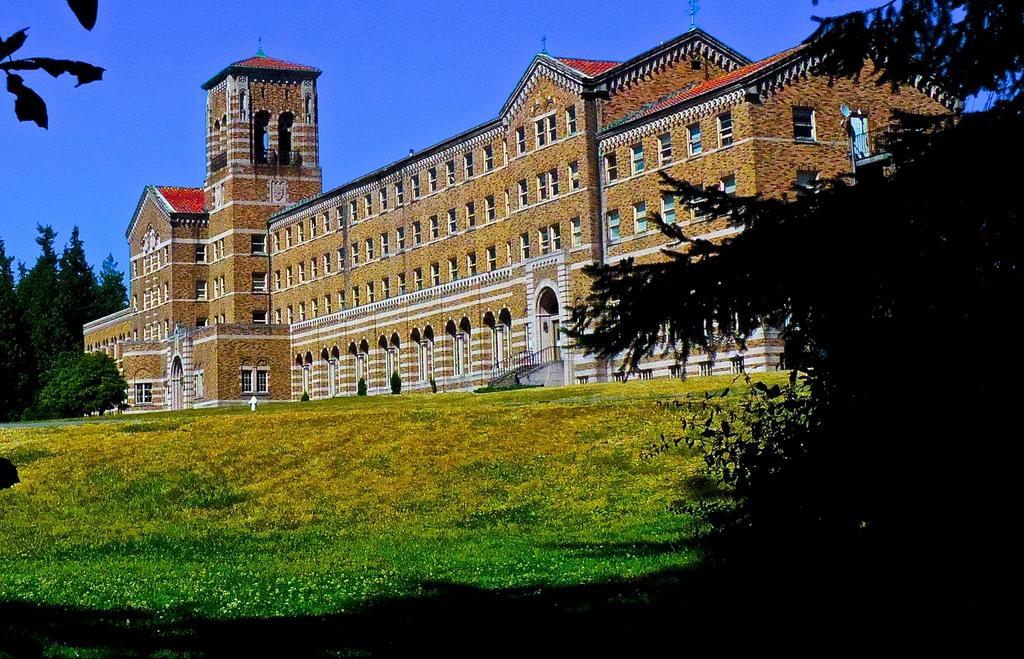In one or two sentences, can you explain what this image depicts? In this image there is a grassland, on the right side there is a tree, in the background there is a building, trees and the sky. 